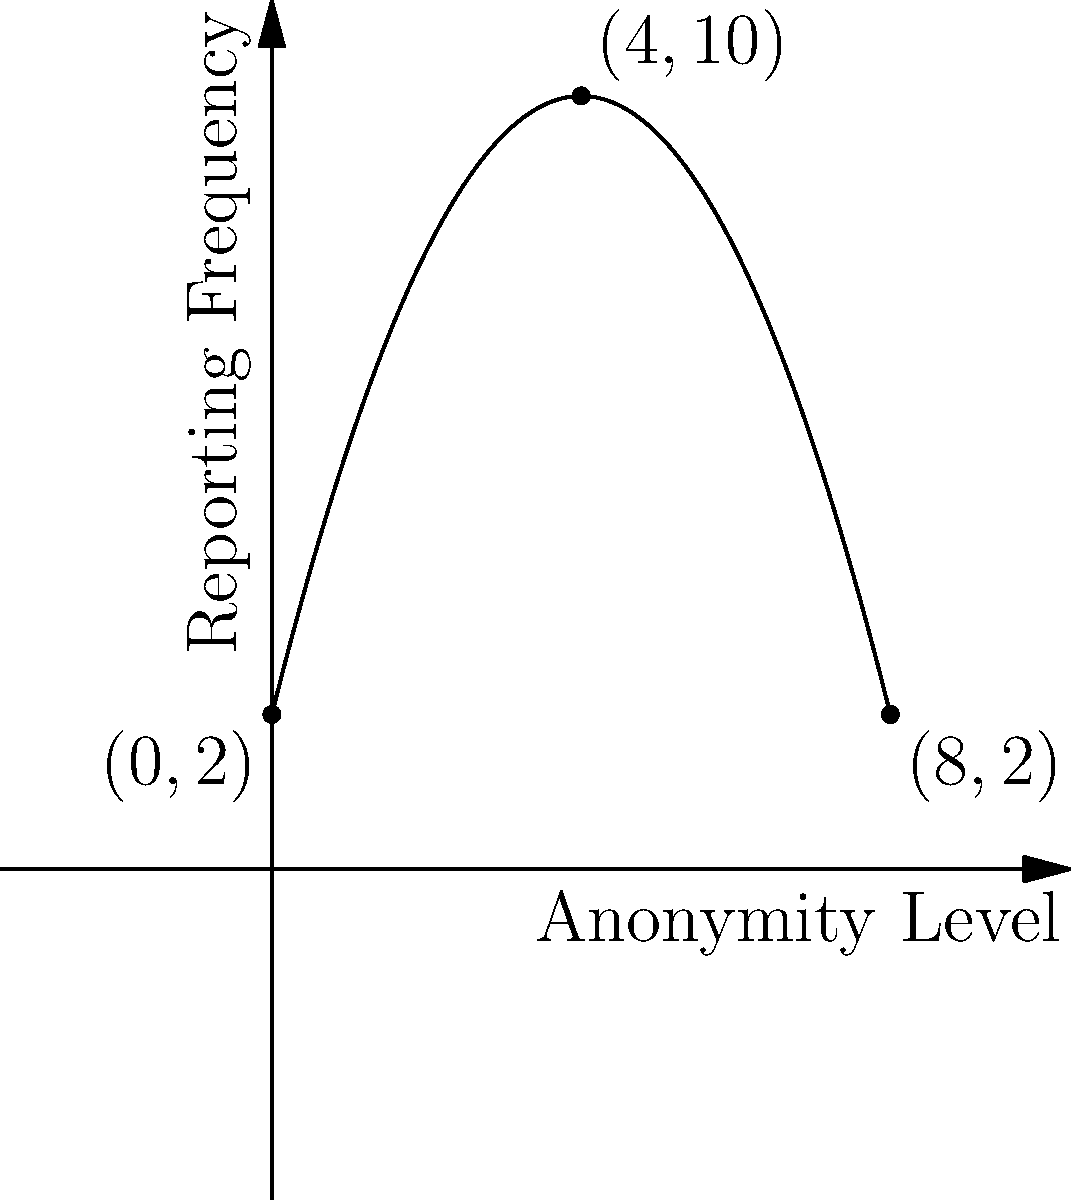The graph shows the relationship between anonymity level and reporting frequency for an internal whistleblowing system. If the relationship is modeled by a quadratic function $f(x) = ax^2 + bx + c$, where $x$ represents the anonymity level and $f(x)$ represents the reporting frequency, what is the value of $a$? To find the value of $a$, we need to use the quadratic function and the given points:

1. We have three points: $(0,2)$, $(4,10)$, and $(8,2)$.

2. The general form of the quadratic function is $f(x) = ax^2 + bx + c$.

3. We can see that the parabola opens downward, so $a$ must be negative.

4. The vertex of the parabola appears to be at $x=4$, which is the midpoint between $x=0$ and $x=8$.

5. For a quadratic function, if the vertex is at $x=4$, we can rewrite it as:
   $f(x) = a(x-4)^2 + k$, where $k$ is the maximum value (10 in this case).

6. Expanding this form: $f(x) = ax^2 - 8ax + 16a + 10$

7. Compare this to the general form: $ax^2 + bx + c$
   We can see that $b = -8a$ and $c = 16a + 10$

8. Now, use the point $(0,2)$:
   $2 = a(0)^2 - 8a(0) + 16a + 10$
   $2 = 16a + 10$
   $-8 = 16a$
   $a = -0.5$

Therefore, the value of $a$ is $-0.5$.
Answer: $-0.5$ 